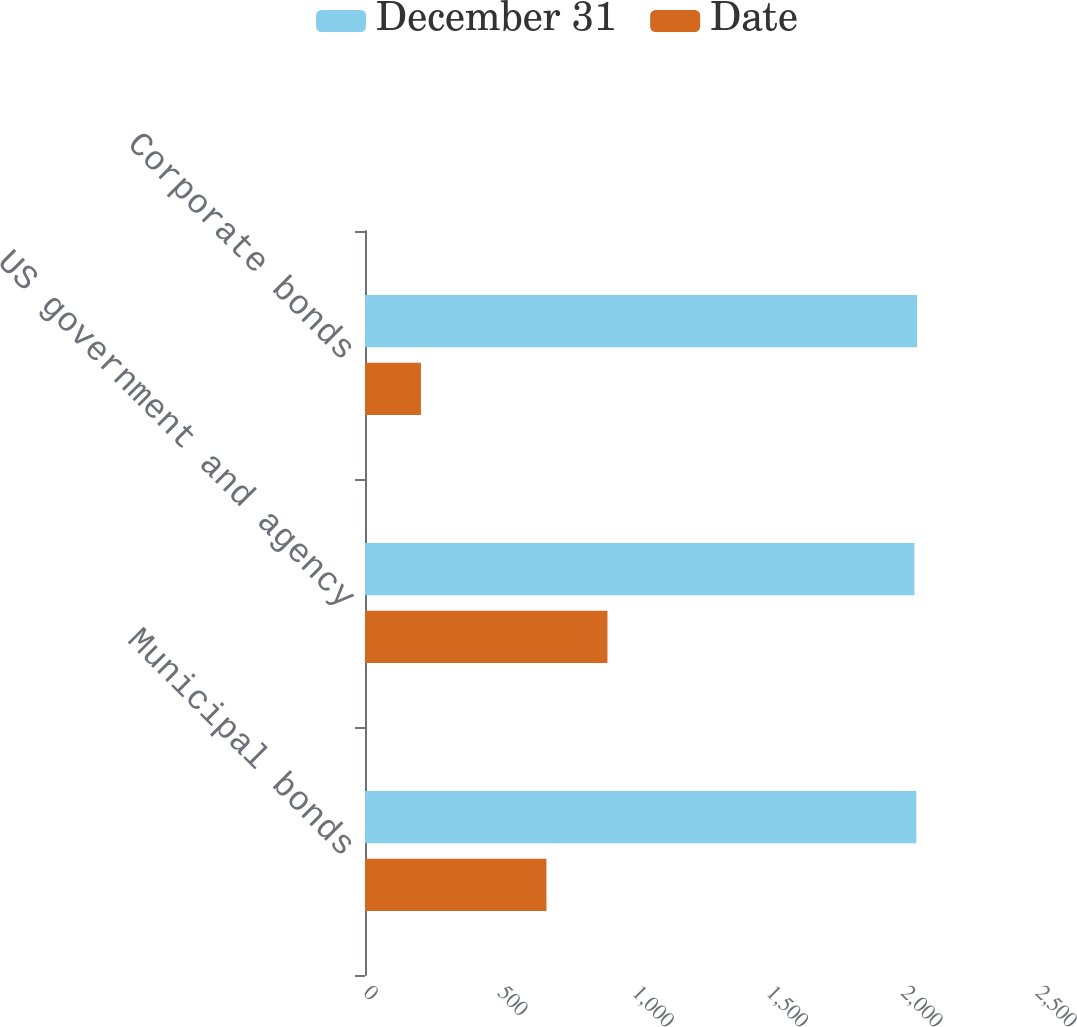Convert chart to OTSL. <chart><loc_0><loc_0><loc_500><loc_500><stacked_bar_chart><ecel><fcel>Municipal bonds<fcel>US government and agency<fcel>Corporate bonds<nl><fcel>December 31<fcel>2051<fcel>2044<fcel>2054<nl><fcel>Date<fcel>675<fcel>902<fcel>208<nl></chart> 